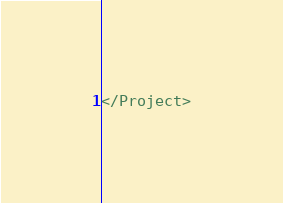<code> <loc_0><loc_0><loc_500><loc_500><_XML_>
</Project>
</code> 